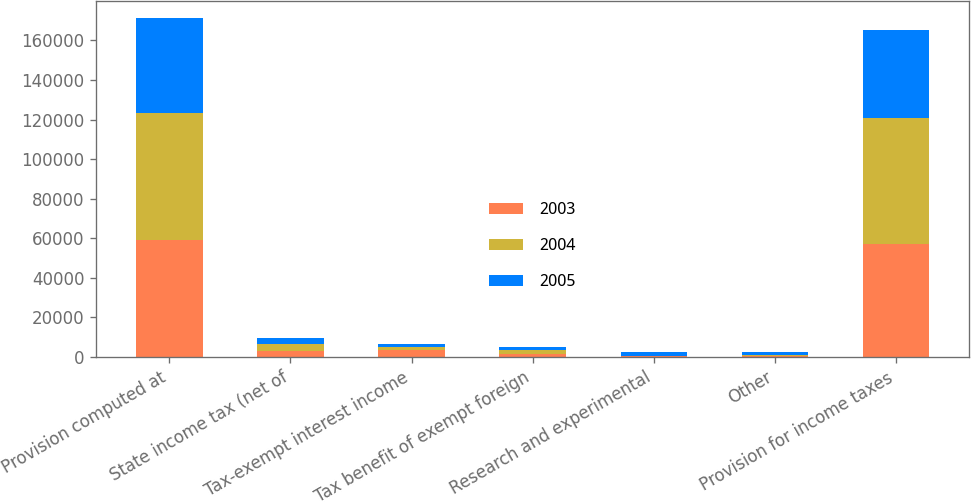Convert chart to OTSL. <chart><loc_0><loc_0><loc_500><loc_500><stacked_bar_chart><ecel><fcel>Provision computed at<fcel>State income tax (net of<fcel>Tax-exempt interest income<fcel>Tax benefit of exempt foreign<fcel>Research and experimental<fcel>Other<fcel>Provision for income taxes<nl><fcel>2003<fcel>58963<fcel>3146<fcel>3301<fcel>1575<fcel>350<fcel>714<fcel>56862<nl><fcel>2004<fcel>64592<fcel>3595<fcel>1767<fcel>1750<fcel>350<fcel>415<fcel>63905<nl><fcel>2005<fcel>47597<fcel>2952<fcel>1674<fcel>1488<fcel>1959<fcel>1318<fcel>44296<nl></chart> 